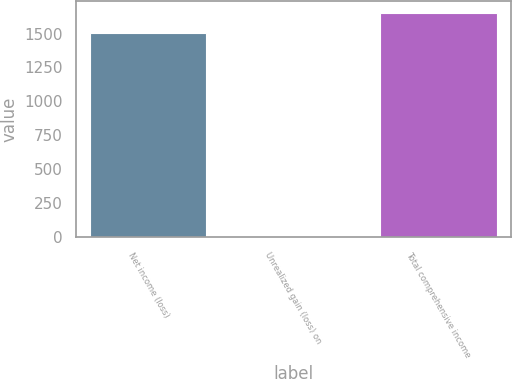Convert chart. <chart><loc_0><loc_0><loc_500><loc_500><bar_chart><fcel>Net income (loss)<fcel>Unrealized gain (loss) on<fcel>Total comprehensive income<nl><fcel>1504.2<fcel>3.6<fcel>1654.62<nl></chart> 